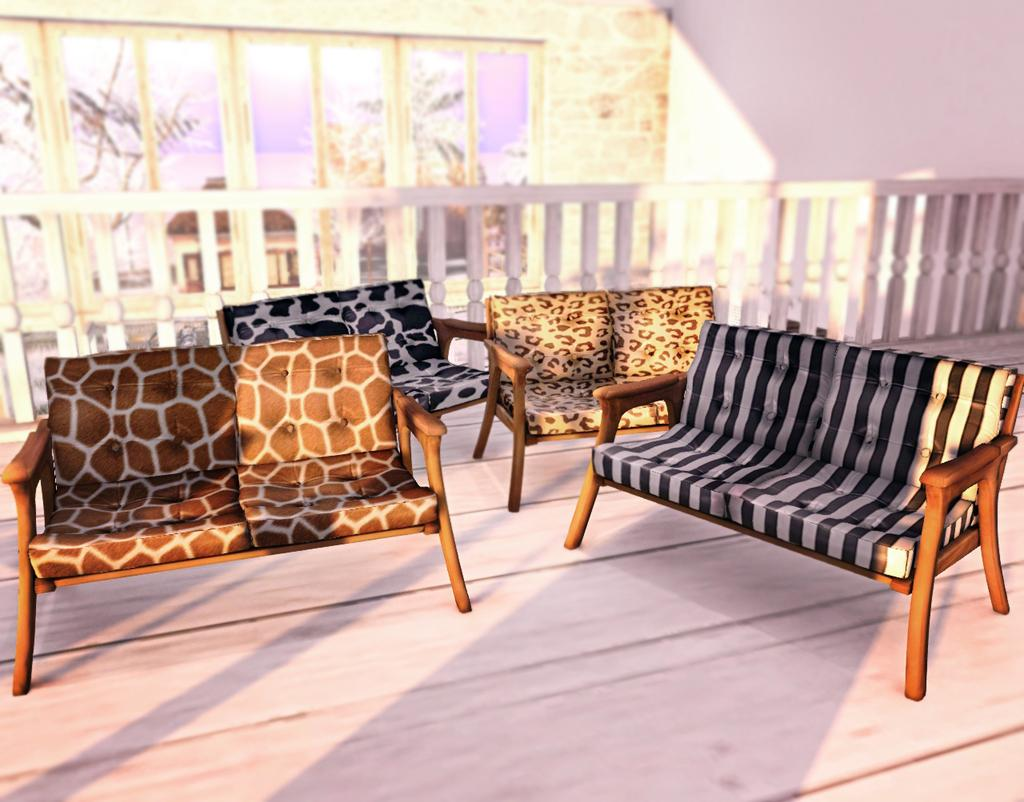What type of furniture is present in the image? There are wooden sofas in the image. What can be seen in the background of the image? There is a white color fence, a frame glass wall, and a white color wall in the background. How many cows are visible through the frame glass wall in the image? There are no cows present in the image, and the frame glass wall does not show any view of the outdoors. 